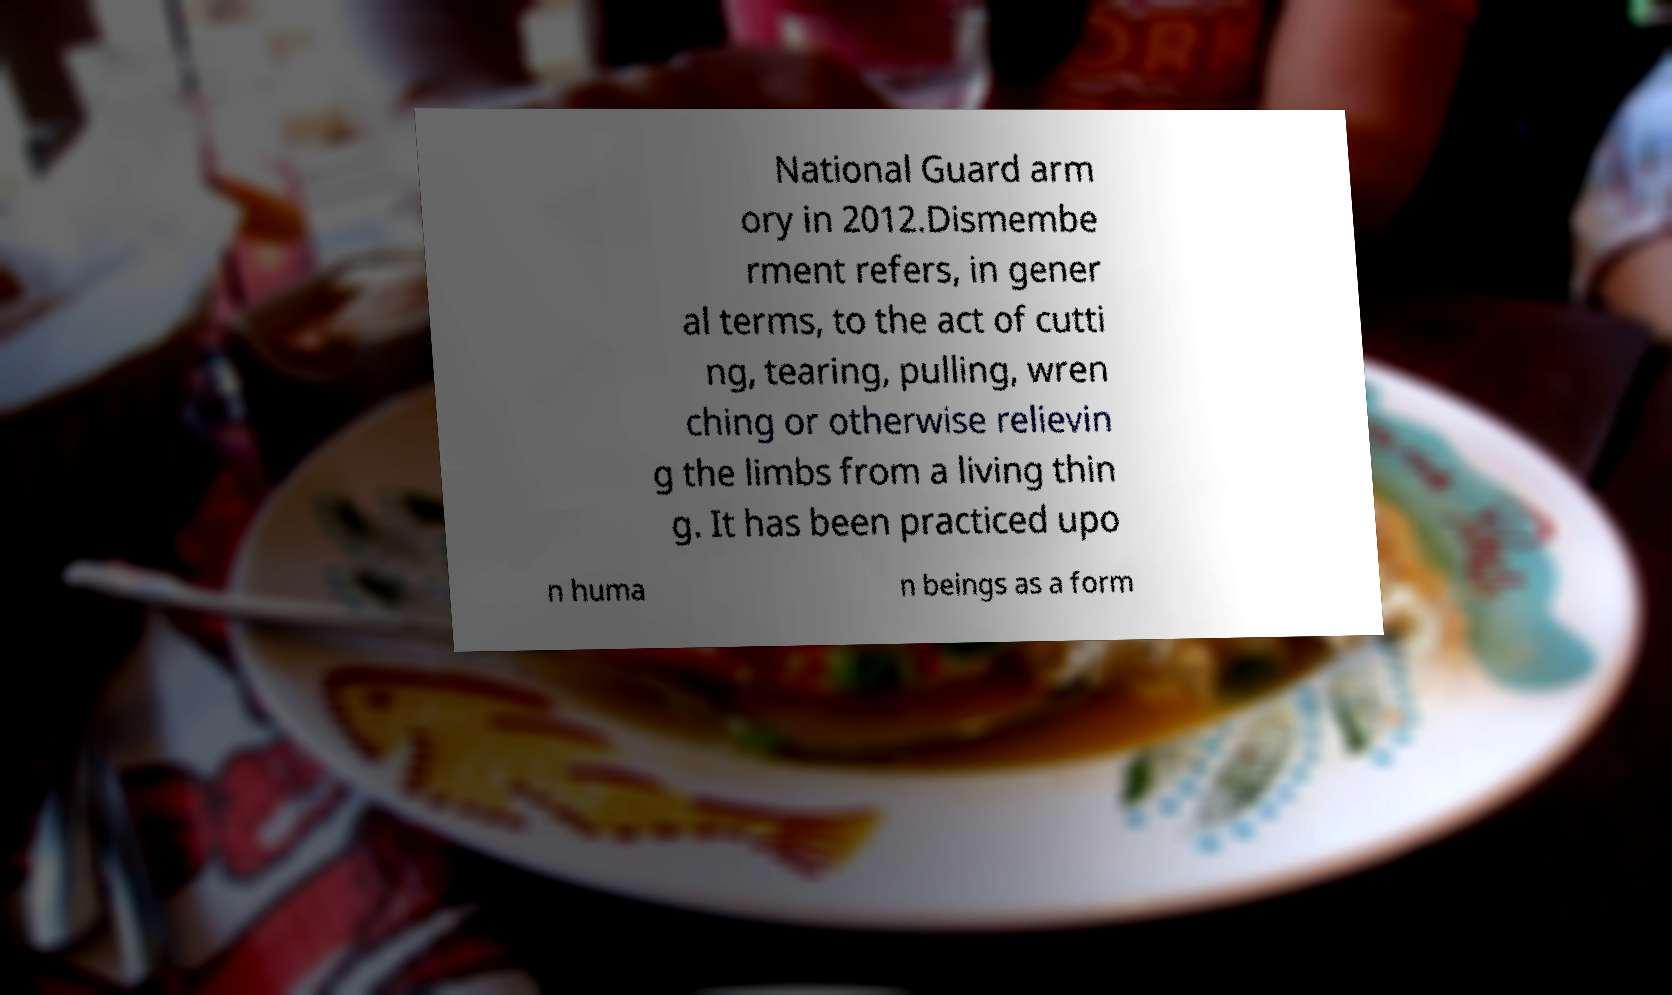For documentation purposes, I need the text within this image transcribed. Could you provide that? National Guard arm ory in 2012.Dismembe rment refers, in gener al terms, to the act of cutti ng, tearing, pulling, wren ching or otherwise relievin g the limbs from a living thin g. It has been practiced upo n huma n beings as a form 